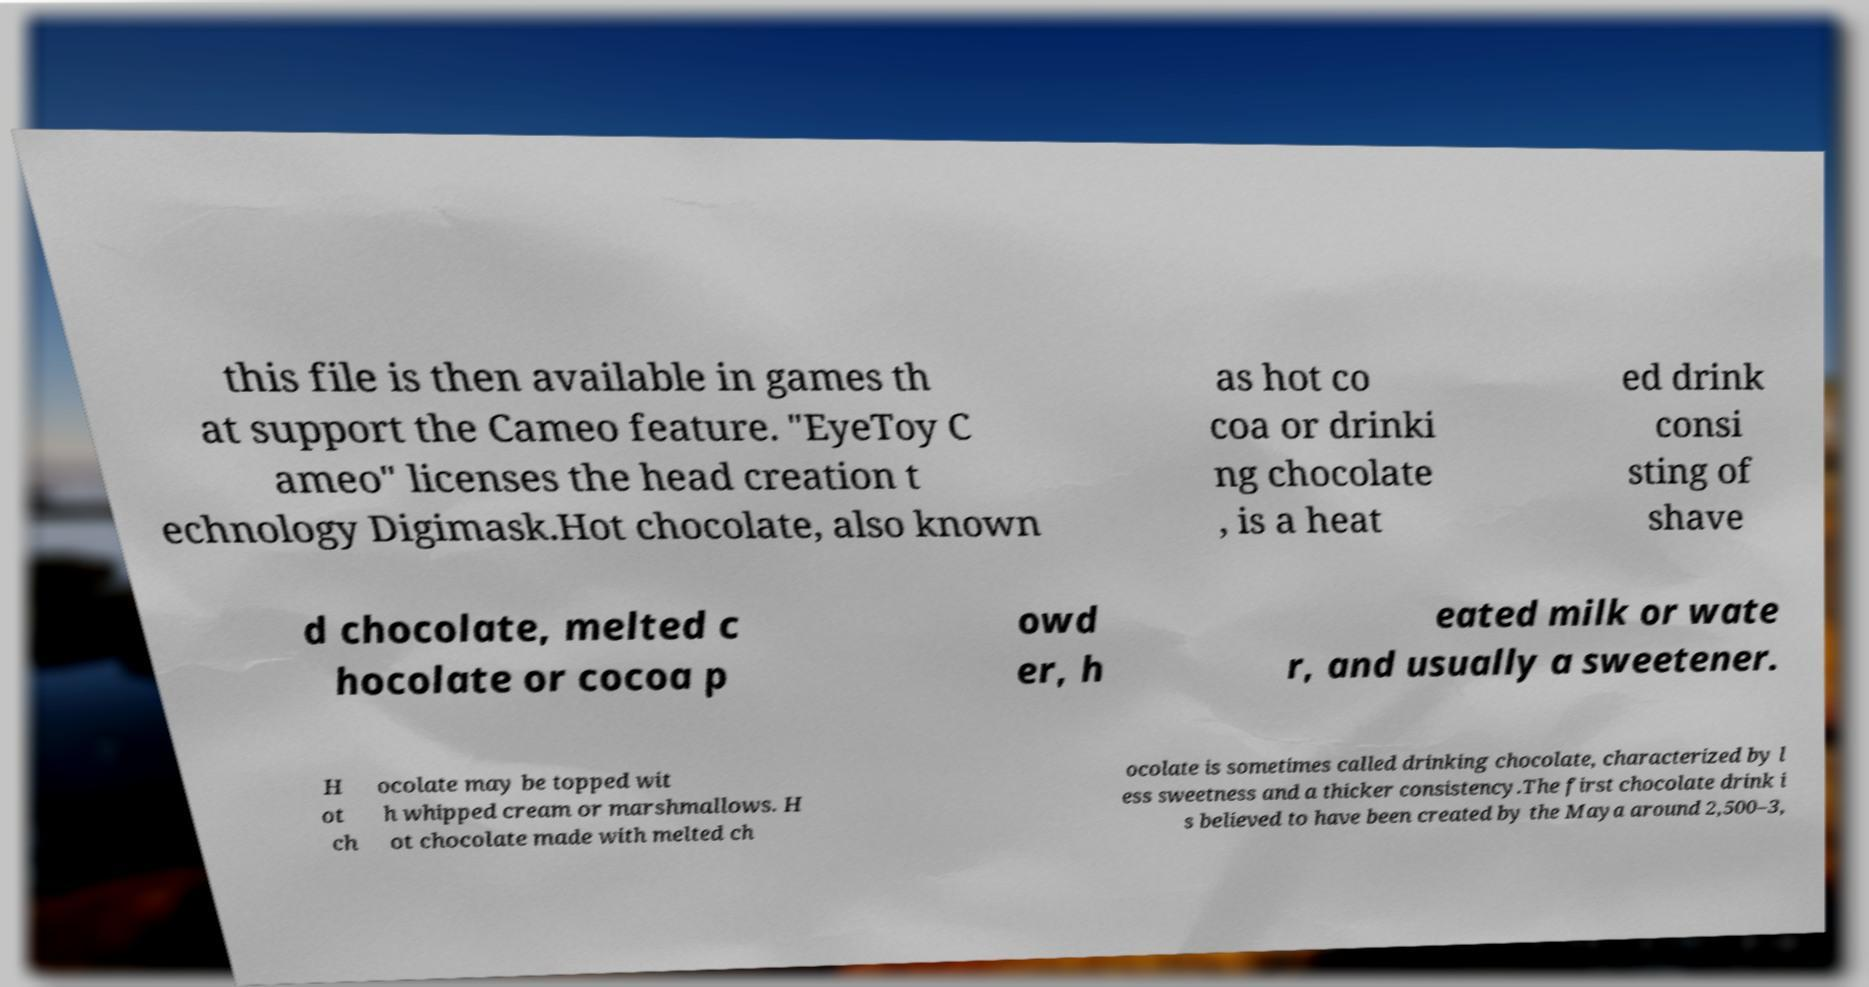I need the written content from this picture converted into text. Can you do that? this file is then available in games th at support the Cameo feature. "EyeToy C ameo" licenses the head creation t echnology Digimask.Hot chocolate, also known as hot co coa or drinki ng chocolate , is a heat ed drink consi sting of shave d chocolate, melted c hocolate or cocoa p owd er, h eated milk or wate r, and usually a sweetener. H ot ch ocolate may be topped wit h whipped cream or marshmallows. H ot chocolate made with melted ch ocolate is sometimes called drinking chocolate, characterized by l ess sweetness and a thicker consistency.The first chocolate drink i s believed to have been created by the Maya around 2,500–3, 